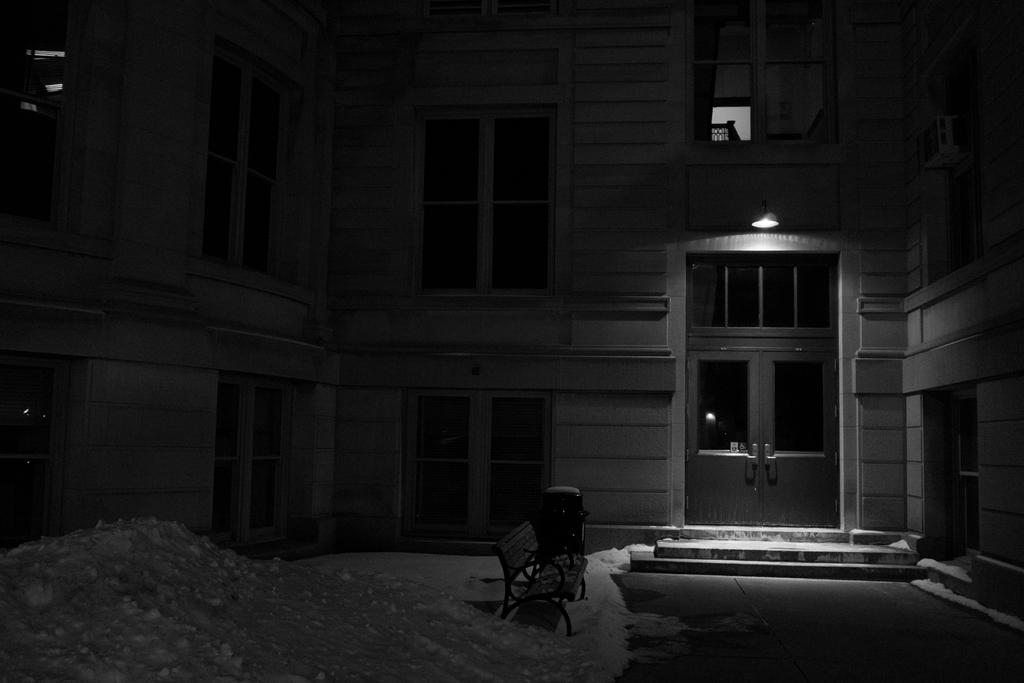What type of structure is present in the image? There is a building in the image. What is located at the bottom of the image? There is a bench at the bottom of the image. What is the weather condition in the image? There is snow in the image. What features can be seen on the building? There are windows and a door visible on the building. Is there any blood visible on the bench in the image? No, there is no blood visible on the bench in the image. 